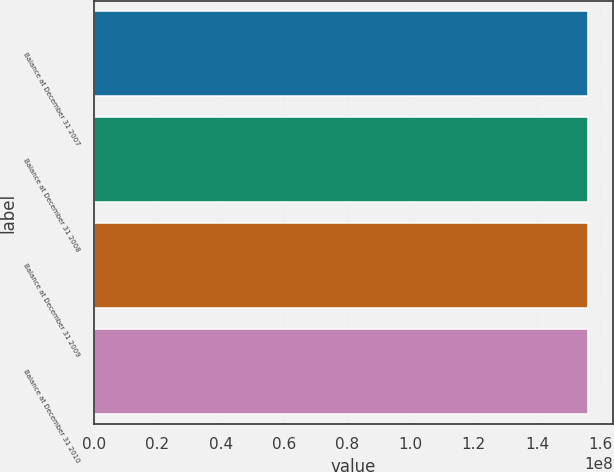Convert chart to OTSL. <chart><loc_0><loc_0><loc_500><loc_500><bar_chart><fcel>Balance at December 31 2007<fcel>Balance at December 31 2008<fcel>Balance at December 31 2009<fcel>Balance at December 31 2010<nl><fcel>1.56234e+08<fcel>1.56234e+08<fcel>1.56234e+08<fcel>1.56234e+08<nl></chart> 